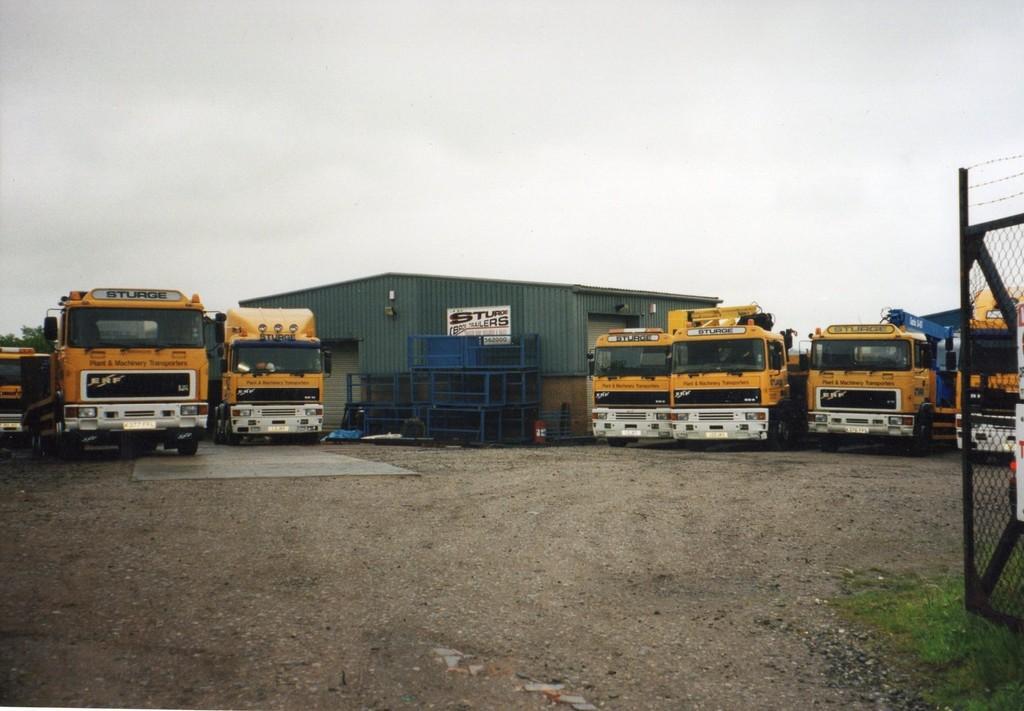Please provide a concise description of this image. In this image I can see land in the front. There is a fence on the right. There are trucks at the back and there is a shed in the center. There is sky at the top. 